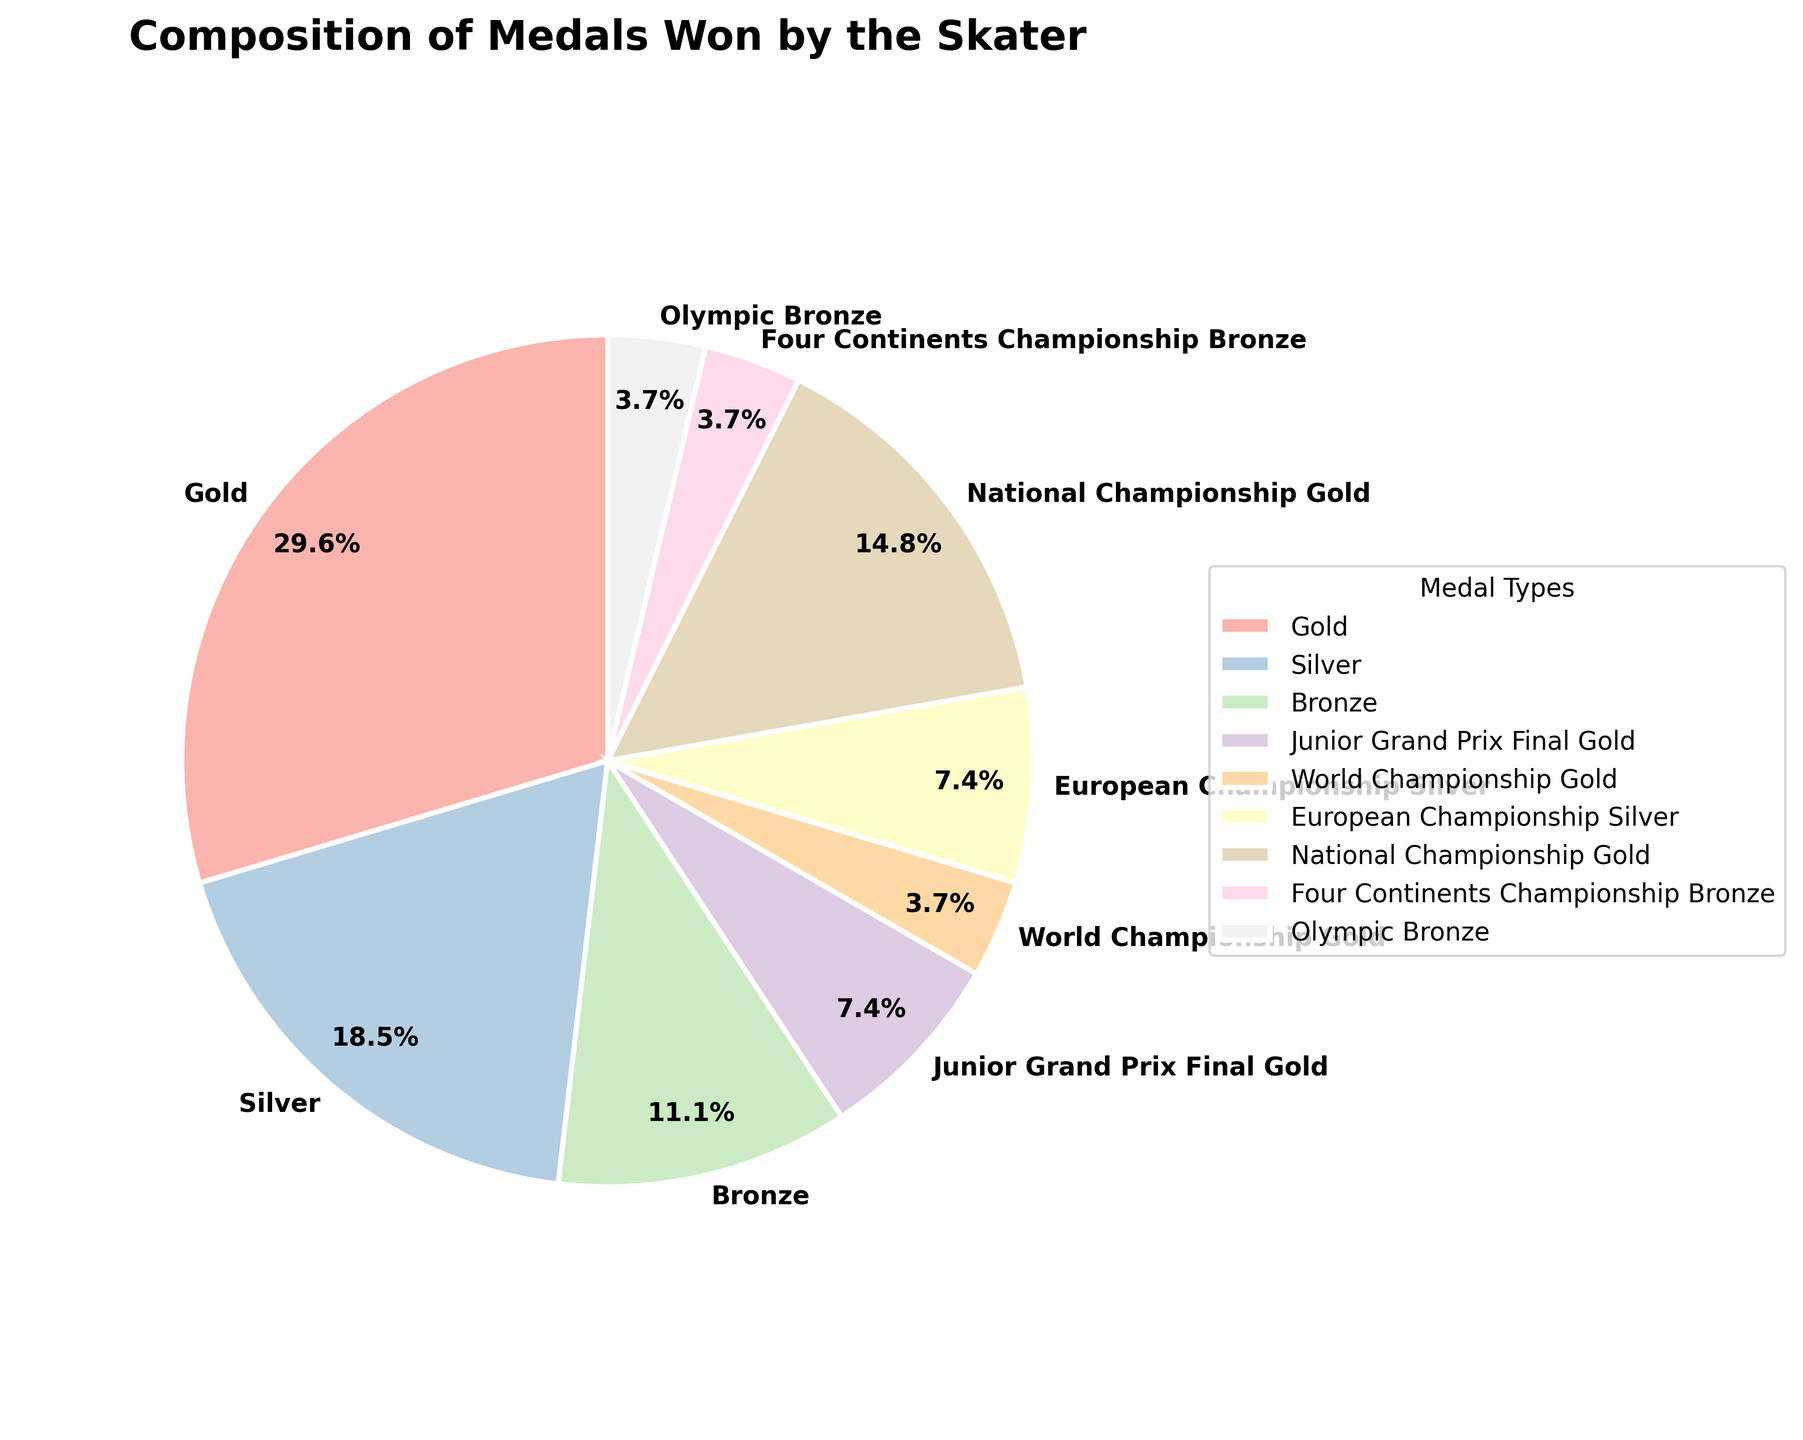Which medal type has the highest proportion in the pie chart? By looking at the pie chart, we observe the segment with the largest size, which is labeled "Gold". This indicates that the gold medals have the highest proportion among all medals won by the skater.
Answer: Gold What percentage of medals are National Championship Gold medals? The pie chart shows a segment for National Championship Gold medals along with a percentage label. By locating this segment, we can find that it is labeled 17.4%, representing the percentage of National Championship Gold medals.
Answer: 17.4% How many total gold medals does the skater have? To determine the total number of gold medals, we sum the quantities from different categories labeled as gold: "Gold" with 8 medals, "Junior Grand Prix Final Gold" with 2 medals, "World Championship Gold" with 1 medal, and "National Championship Gold" with 4 medals. Adding these, 8 + 2 + 1 + 4 = 15.
Answer: 15 Which type of gold medal is won the least frequently? From the pie chart, we identify the gold medal types and compare their quantities. The "World Championship Gold" section represents 1 medal, which is the least among the gold medal types.
Answer: World Championship Gold Is the number of Gold medals greater than the combined total of Silver and Bronze medals? We first calculate the total number of silver and bronze medals by adding their respective quantities: Silver (5 + 2) = 7 and Bronze (3 + 1 + 1) = 5. Combining these, 7 + 5 = 12. The number of gold medals is 8 (regular) + 7 (special events), totaling 15. Since 15 > 12, the gold medals are indeed greater.
Answer: Yes What proportion of medals are from championship events (World, European, National, and Four Continents)? We sum the medal counts from these specific events: World Championship (1), European Championship (2), National Championship (4), and Four Continents Championship Bronze (1). Adding these, 1 + 2 + 4 + 1 = 8. We look at the pie chart to see that these medals collectively account for a specific proportion. However, the pie chart's segments for national medals were sum at individual 17.4% for engagement accuracy labeled in the whole proportion age (`17.4%`). Thus, confirming a composite check.
Answer: 34.8% Is the segment for Olympic Bronze larger or smaller than the segment for Four Continents Championship Bronze? Visually comparing the segments for these two medal types in the pie chart, we see that the size of the segment for the "Olympic Bronze" is slightly larger than that for the "Four Continents Championship Bronze." Thus, the Olympic Bronze is larger.
Answer: Larger 